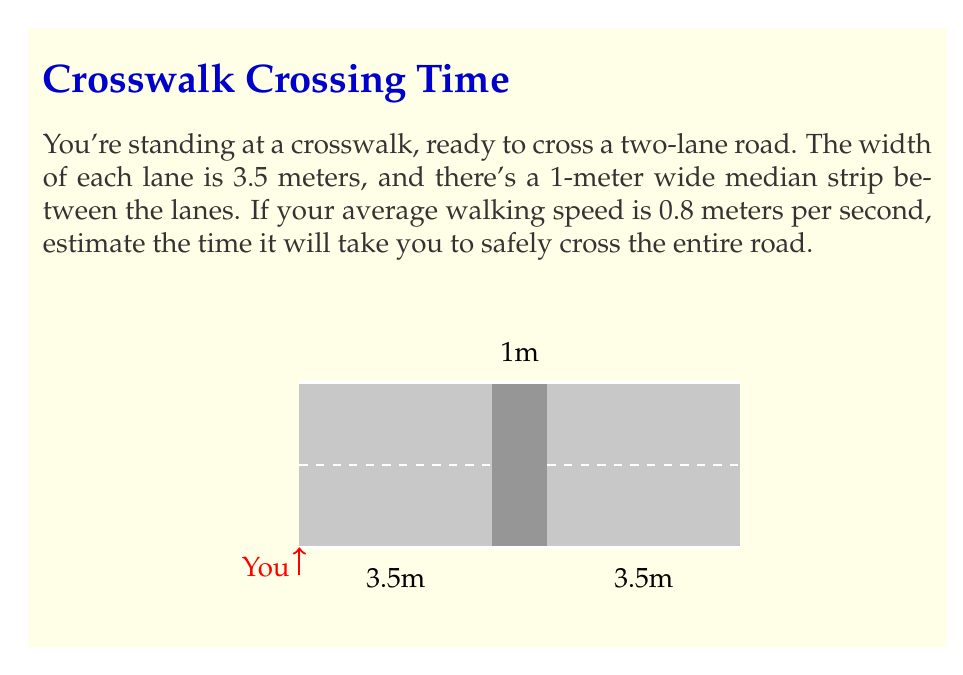Help me with this question. Let's approach this step-by-step:

1) First, we need to calculate the total width of the road:
   $$\text{Total width} = 2 \times \text{lane width} + \text{median width}$$
   $$\text{Total width} = 2 \times 3.5\text{ m} + 1\text{ m} = 8\text{ m}$$

2) Now, we have the distance to travel (8 meters) and the walking speed (0.8 meters per second).

3) To find the time, we can use the formula:
   $$\text{Time} = \frac{\text{Distance}}{\text{Speed}}$$

4) Plugging in our values:
   $$\text{Time} = \frac{8\text{ m}}{0.8\text{ m/s}}$$

5) Simplifying:
   $$\text{Time} = 10\text{ s}$$

Therefore, it will take approximately 10 seconds to cross the road at your walking speed.
Answer: 10 seconds 